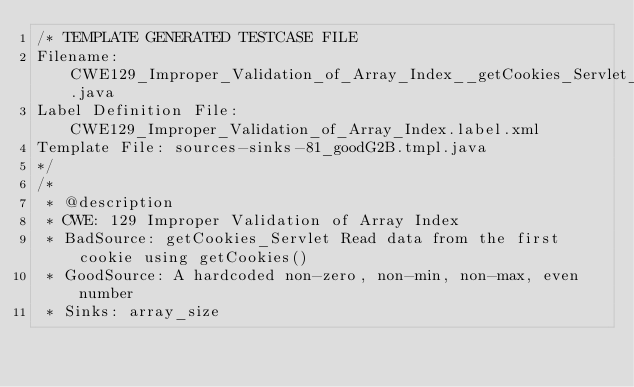Convert code to text. <code><loc_0><loc_0><loc_500><loc_500><_Java_>/* TEMPLATE GENERATED TESTCASE FILE
Filename: CWE129_Improper_Validation_of_Array_Index__getCookies_Servlet_array_size_81_goodG2B.java
Label Definition File: CWE129_Improper_Validation_of_Array_Index.label.xml
Template File: sources-sinks-81_goodG2B.tmpl.java
*/
/*
 * @description
 * CWE: 129 Improper Validation of Array Index
 * BadSource: getCookies_Servlet Read data from the first cookie using getCookies()
 * GoodSource: A hardcoded non-zero, non-min, non-max, even number
 * Sinks: array_size</code> 